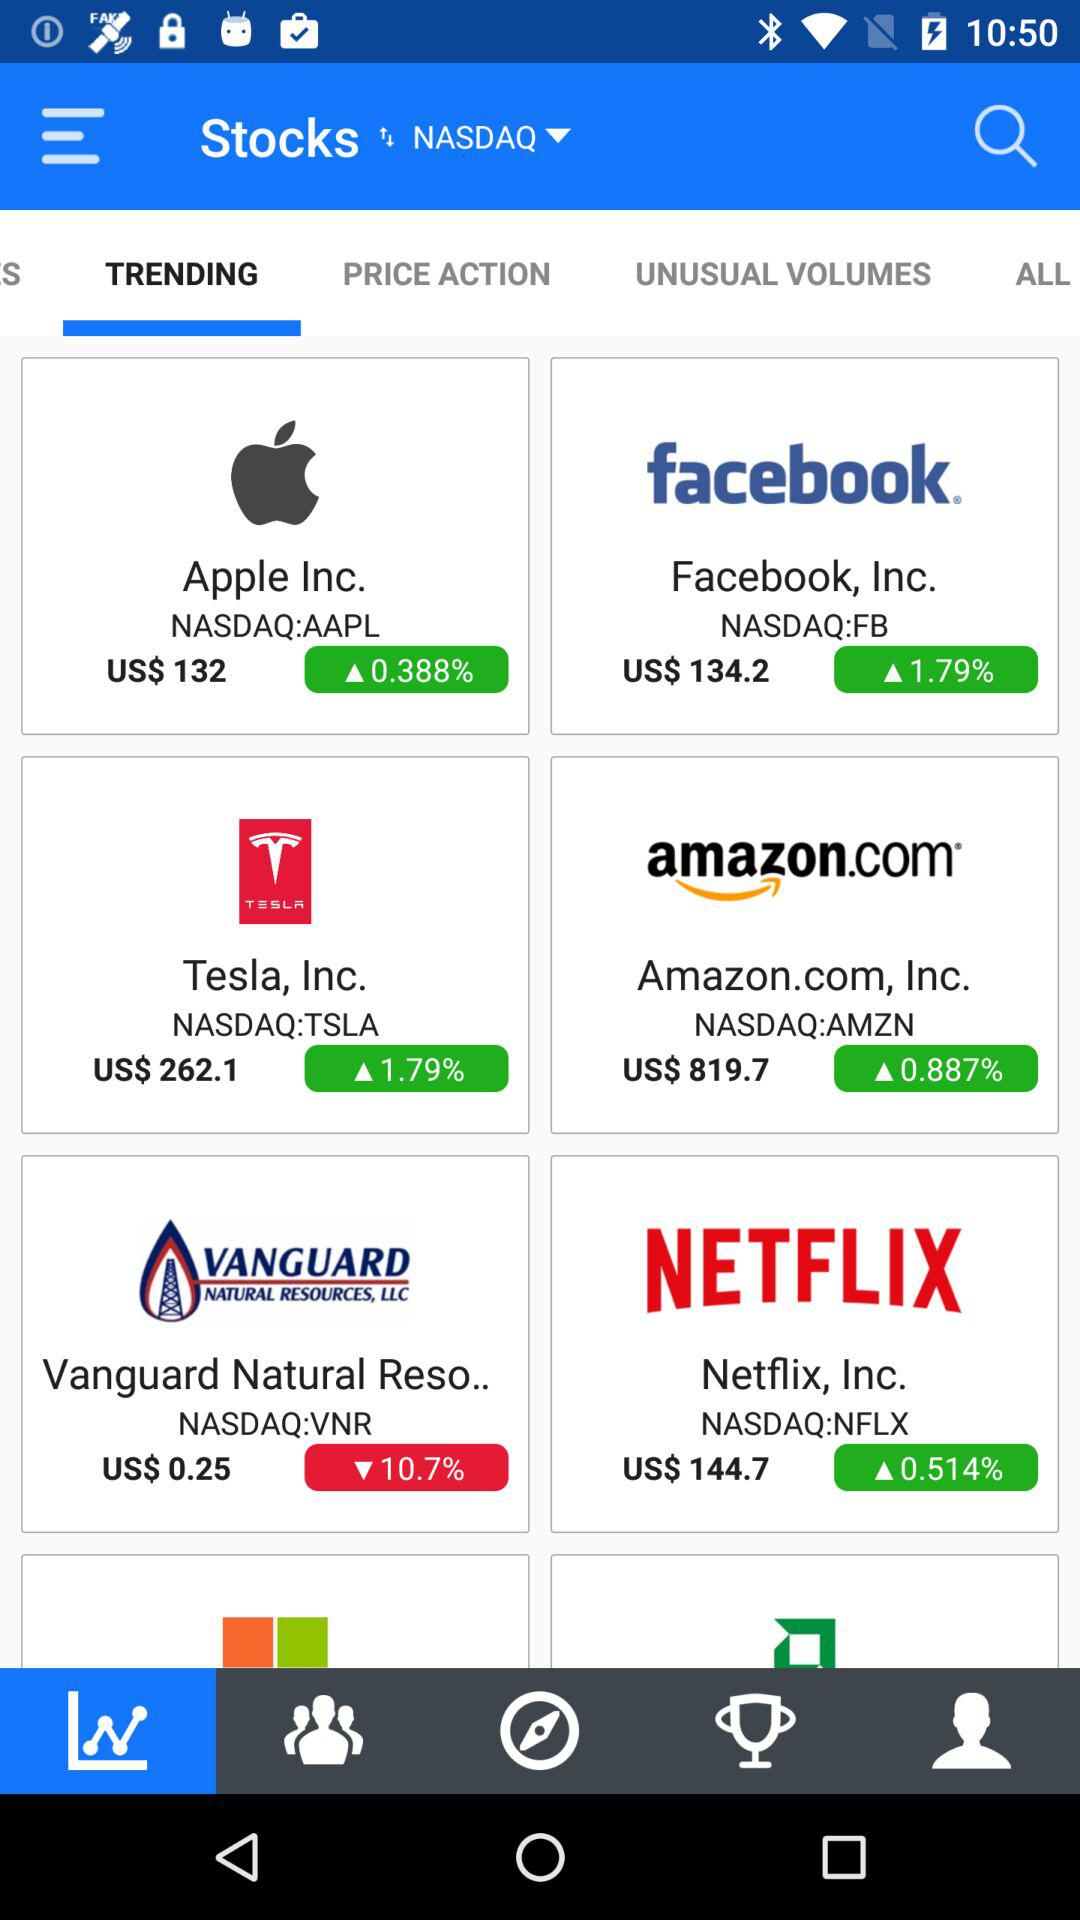What is the percentage increase in "Facebook" stock? The percentage increase in "Facebook" stock is 1.79. 